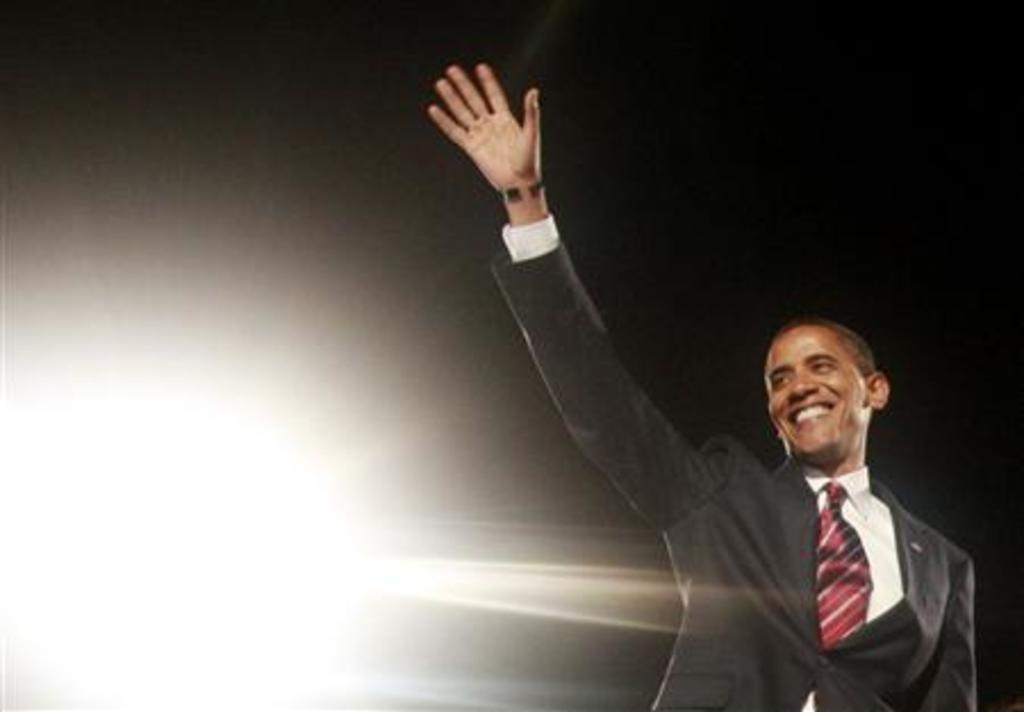What is the main subject of the image? The main subject of the image is a man. What type of clothing is the man wearing? The man is wearing a blazer, a shirt, and a tie. What is the man's facial expression in the image? The man is smiling in the image. How would you describe the background of the image? The background of the image is dark and bright. What invention can be seen in the man's hand in the image? There is no invention visible in the man's hand in the image. What type of smell is associated with the man's tie in the image? There is no mention of smell in the image, and the man's tie does not have a scent. 